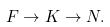Convert formula to latex. <formula><loc_0><loc_0><loc_500><loc_500>F \to K \to N .</formula> 